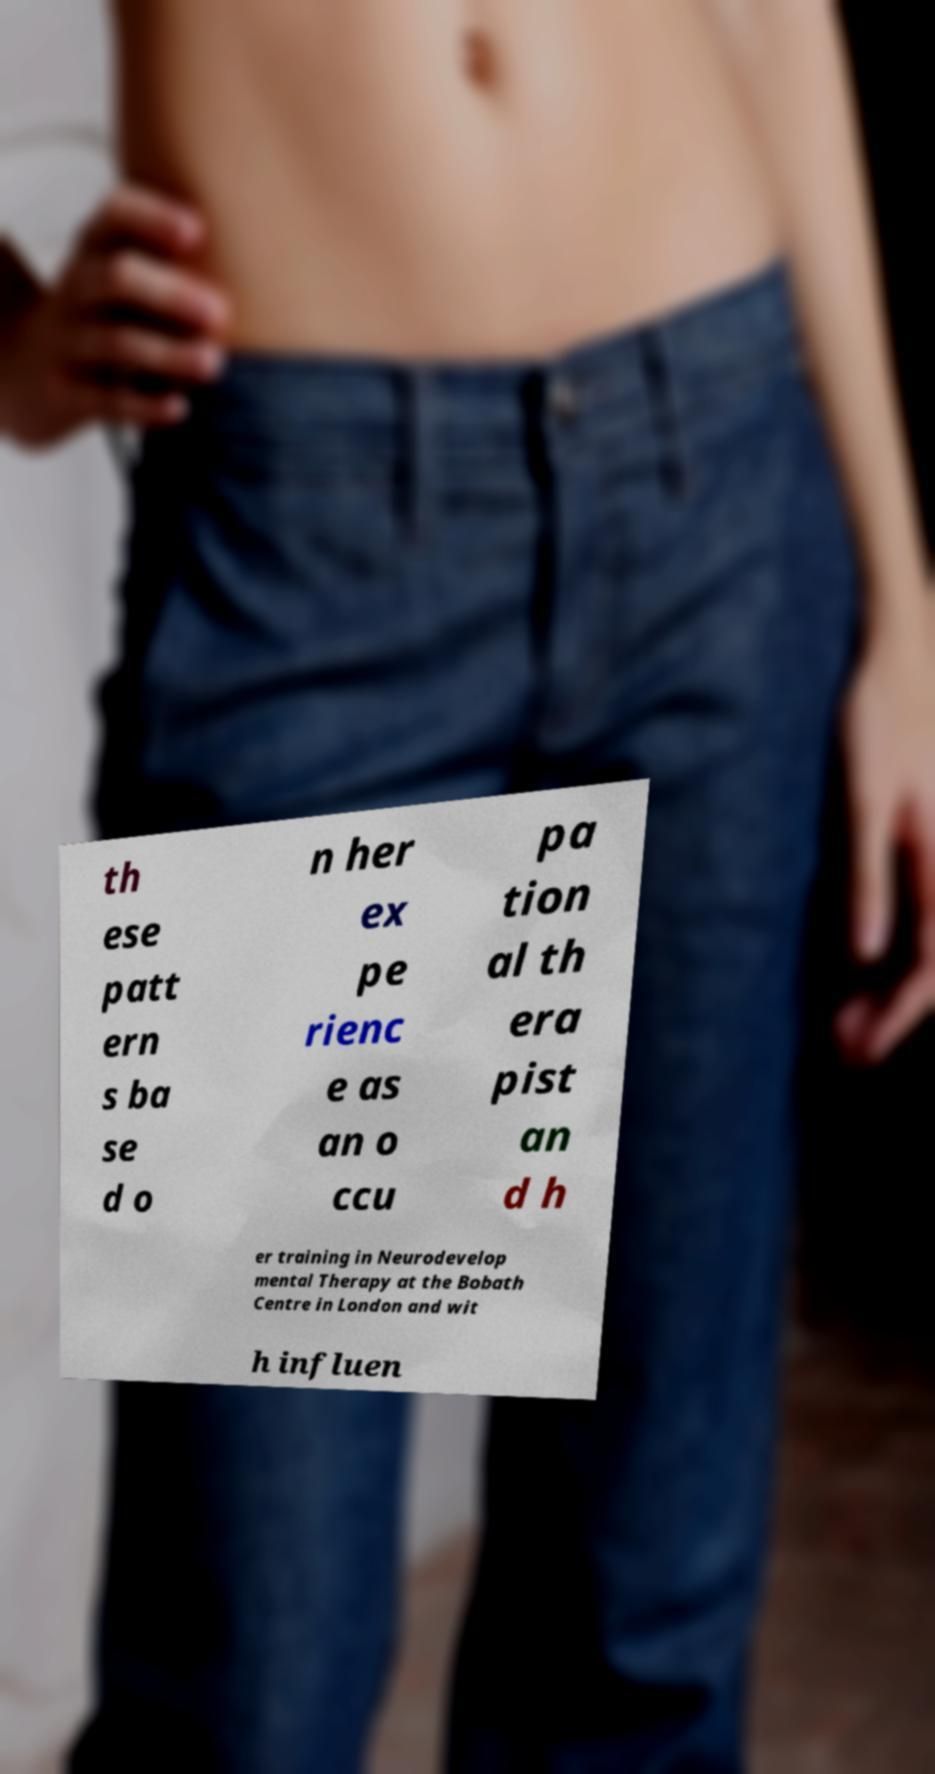For documentation purposes, I need the text within this image transcribed. Could you provide that? th ese patt ern s ba se d o n her ex pe rienc e as an o ccu pa tion al th era pist an d h er training in Neurodevelop mental Therapy at the Bobath Centre in London and wit h influen 